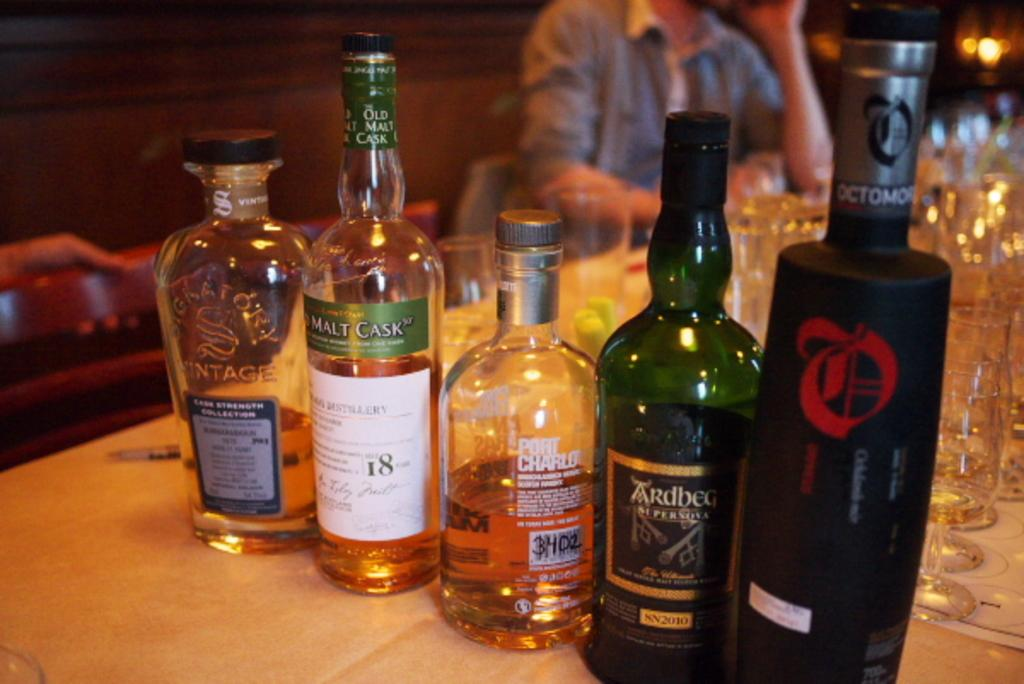<image>
Provide a brief description of the given image. A row of bottles are lined up on a counter including a green bottle with a label that reads, "Ardbeg." 